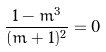<formula> <loc_0><loc_0><loc_500><loc_500>\frac { 1 - m ^ { 3 } } { ( m + 1 ) ^ { 2 } } = 0</formula> 